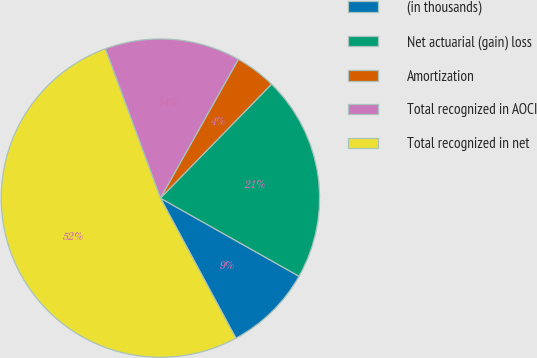Convert chart to OTSL. <chart><loc_0><loc_0><loc_500><loc_500><pie_chart><fcel>(in thousands)<fcel>Net actuarial (gain) loss<fcel>Amortization<fcel>Total recognized in AOCI<fcel>Total recognized in net<nl><fcel>8.97%<fcel>20.87%<fcel>4.16%<fcel>13.77%<fcel>52.24%<nl></chart> 